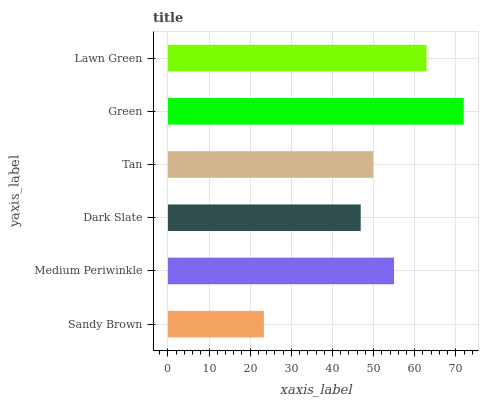Is Sandy Brown the minimum?
Answer yes or no. Yes. Is Green the maximum?
Answer yes or no. Yes. Is Medium Periwinkle the minimum?
Answer yes or no. No. Is Medium Periwinkle the maximum?
Answer yes or no. No. Is Medium Periwinkle greater than Sandy Brown?
Answer yes or no. Yes. Is Sandy Brown less than Medium Periwinkle?
Answer yes or no. Yes. Is Sandy Brown greater than Medium Periwinkle?
Answer yes or no. No. Is Medium Periwinkle less than Sandy Brown?
Answer yes or no. No. Is Medium Periwinkle the high median?
Answer yes or no. Yes. Is Tan the low median?
Answer yes or no. Yes. Is Sandy Brown the high median?
Answer yes or no. No. Is Green the low median?
Answer yes or no. No. 